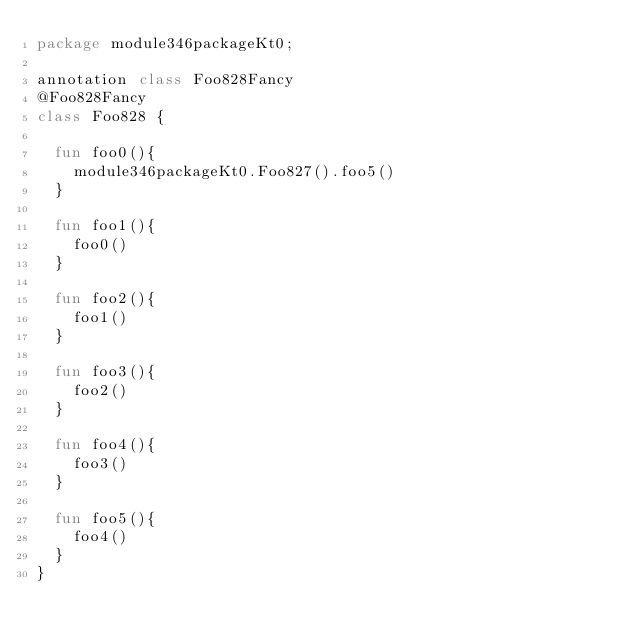Convert code to text. <code><loc_0><loc_0><loc_500><loc_500><_Kotlin_>package module346packageKt0;

annotation class Foo828Fancy
@Foo828Fancy
class Foo828 {

  fun foo0(){
    module346packageKt0.Foo827().foo5()
  }

  fun foo1(){
    foo0()
  }

  fun foo2(){
    foo1()
  }

  fun foo3(){
    foo2()
  }

  fun foo4(){
    foo3()
  }

  fun foo5(){
    foo4()
  }
}</code> 